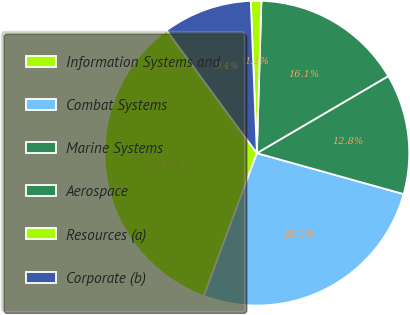Convert chart to OTSL. <chart><loc_0><loc_0><loc_500><loc_500><pie_chart><fcel>Information Systems and<fcel>Combat Systems<fcel>Marine Systems<fcel>Aerospace<fcel>Resources (a)<fcel>Corporate (b)<nl><fcel>34.26%<fcel>26.33%<fcel>12.77%<fcel>16.09%<fcel>1.11%<fcel>9.45%<nl></chart> 